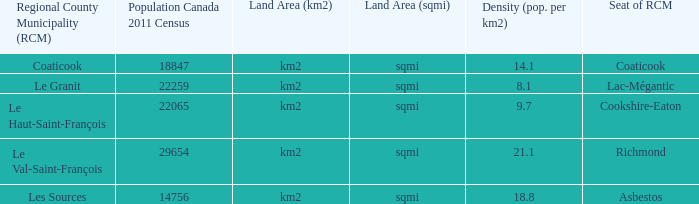1? Km2 (sqmi). 